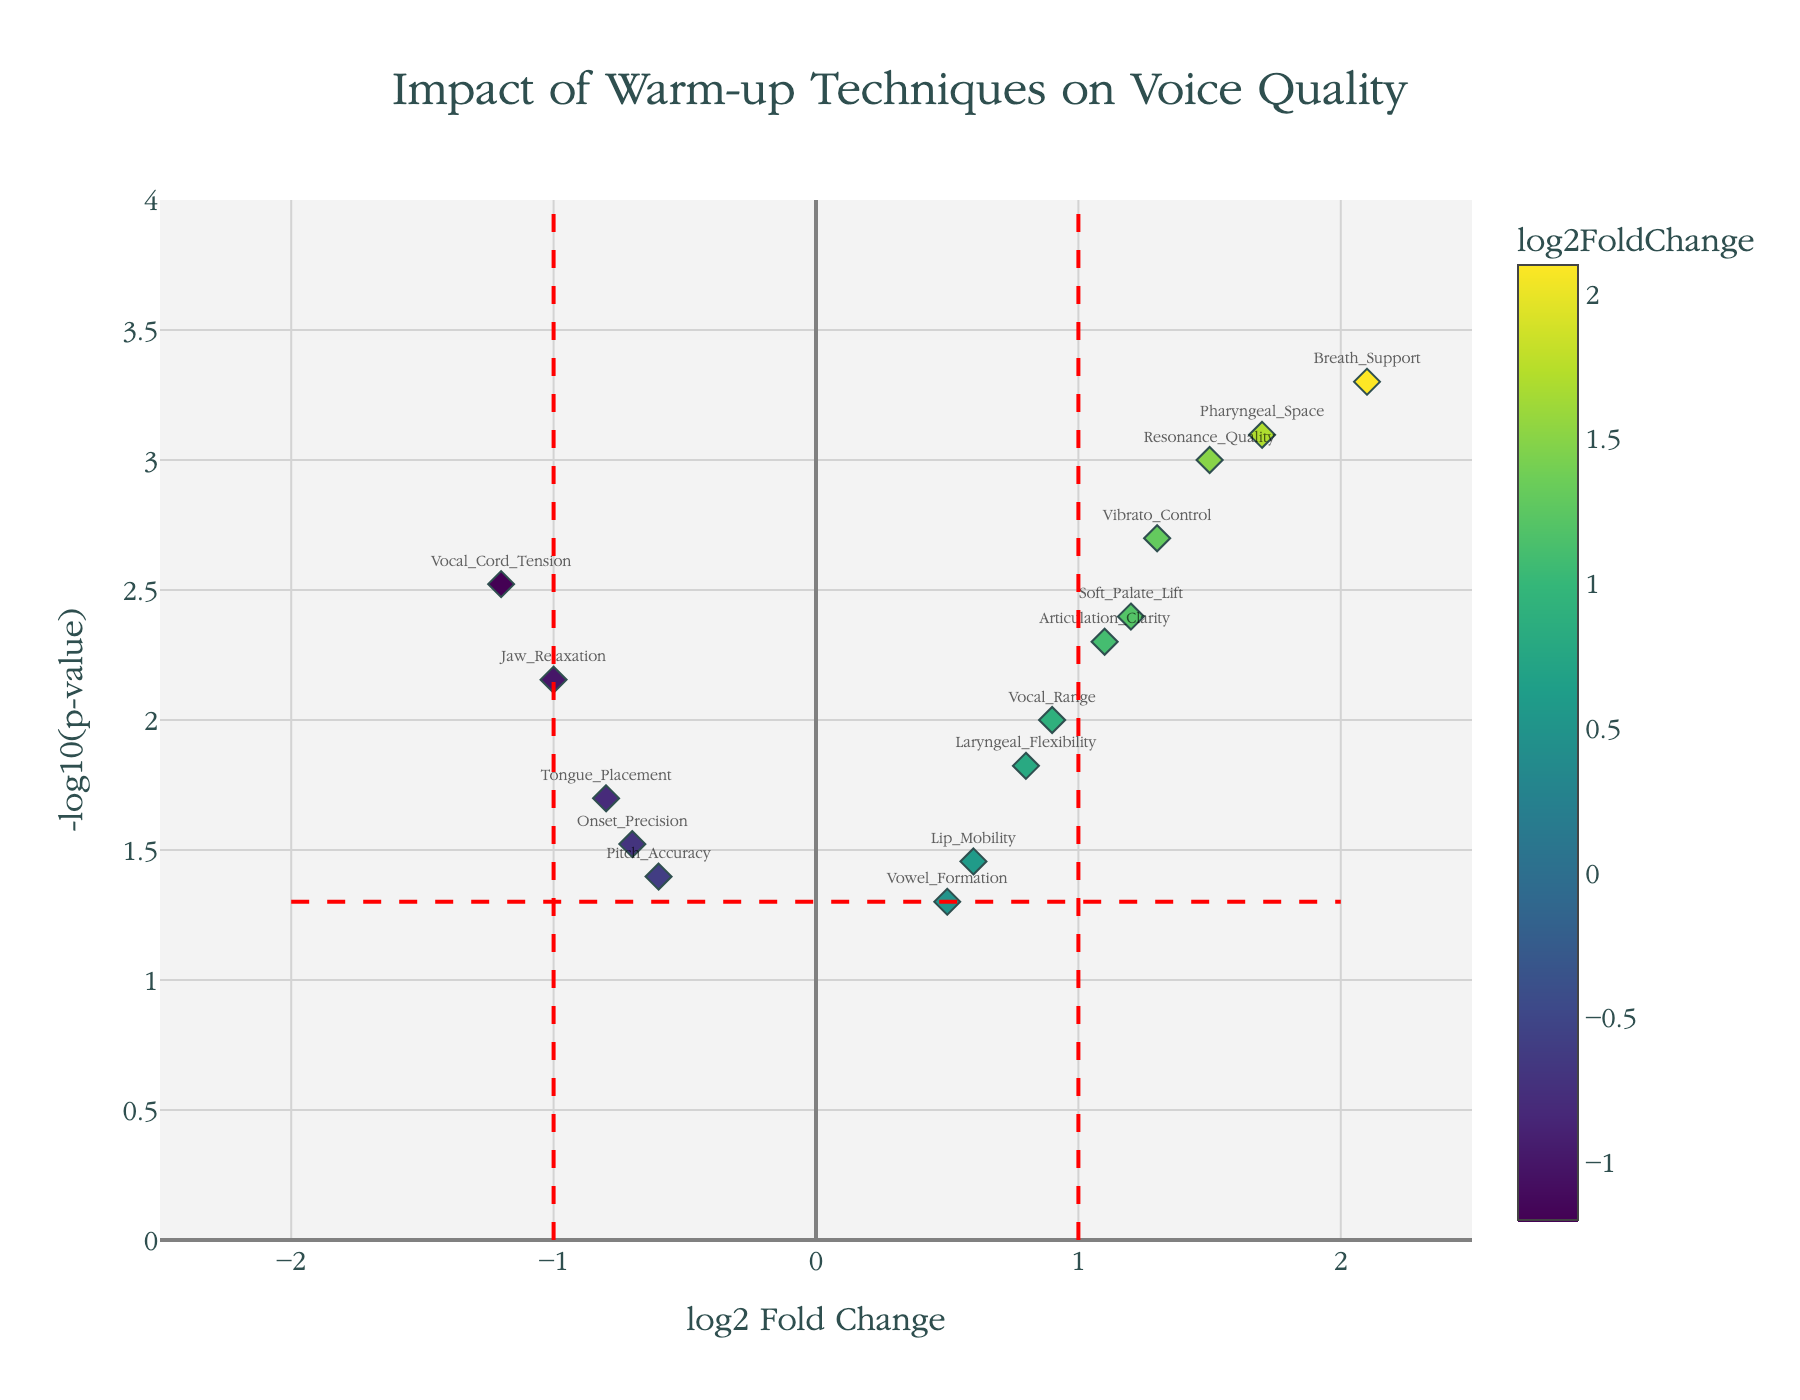what is the title of the plot? The title is typically located at the top of the figure and is set by the plot's layout settings. Here, it's specified in the code.
Answer: Impact of Warm-up Techniques on Voice Quality How are the genes color-coded in the plot? The genes are color-coded based on their log2FoldChange values, which is shown in the Viridis color scale. The more intense the color, the higher the log2FoldChange value.
Answer: By log2FoldChange Which gene has the highest log2 fold change? By looking at the x-axis of the plot and finding the rightmost point, we can identify the gene with the highest log2FoldChange value.
Answer: Breath_Support How many genes have a p-value less than 0.01? To find this, look at the y-axis and identify data points with a -log10(p-value) greater than -log10(0.01), which is 2.
Answer: Seven genes What is the significance threshold line for p-value represented on the plot? The significance threshold line for p-value is represented on the y-axis at -log10(0.05), which approximately equals 1.3.
Answer: -log10(0.05) Which genes lie outside the significance thresholds on both sides of the log2 fold change? By identifying genes that are beyond the red dashed lines at -1 and 1 log2FoldChange and also above the p-value threshold line, we see which genes are significantly affected.
Answer: Resonance_Quality, Breath_Support, Vibrato_Control, Pharyngeal_Space Is Vocal_Cord_Tension significantly downregulated? Check if the gene is left of -1 on the x-axis and above the y-line at -log10(0.05).
Answer: Yes Compare the log2 fold change and p-value of Articulation_Clarity and Soft_Palate_Lift. Which has higher values for both metrics? By examining their positions on the plot: Articulation_Clarity at (1.1, 2.3) vs. Soft_Palate_Lift at (1.2, 2.4), Soft_Palate_Lift is slighty higher in both.
Answer: Soft_Palate_Lift Does Tongue_Placement fall within the non-significant range of log2 fold changes? The non-significant range for log2FoldChange is between -1 and 1. Tongue_Placement, with log2FoldChange of -0.8, is within this range.
Answer: Yes What is the log2 fold change and p-value for Laryngeal_Flexibility? By looking at the hover information if present, or by identifying its position, we find its coordinates on the plot.
Answer: 0.8, 0.015 